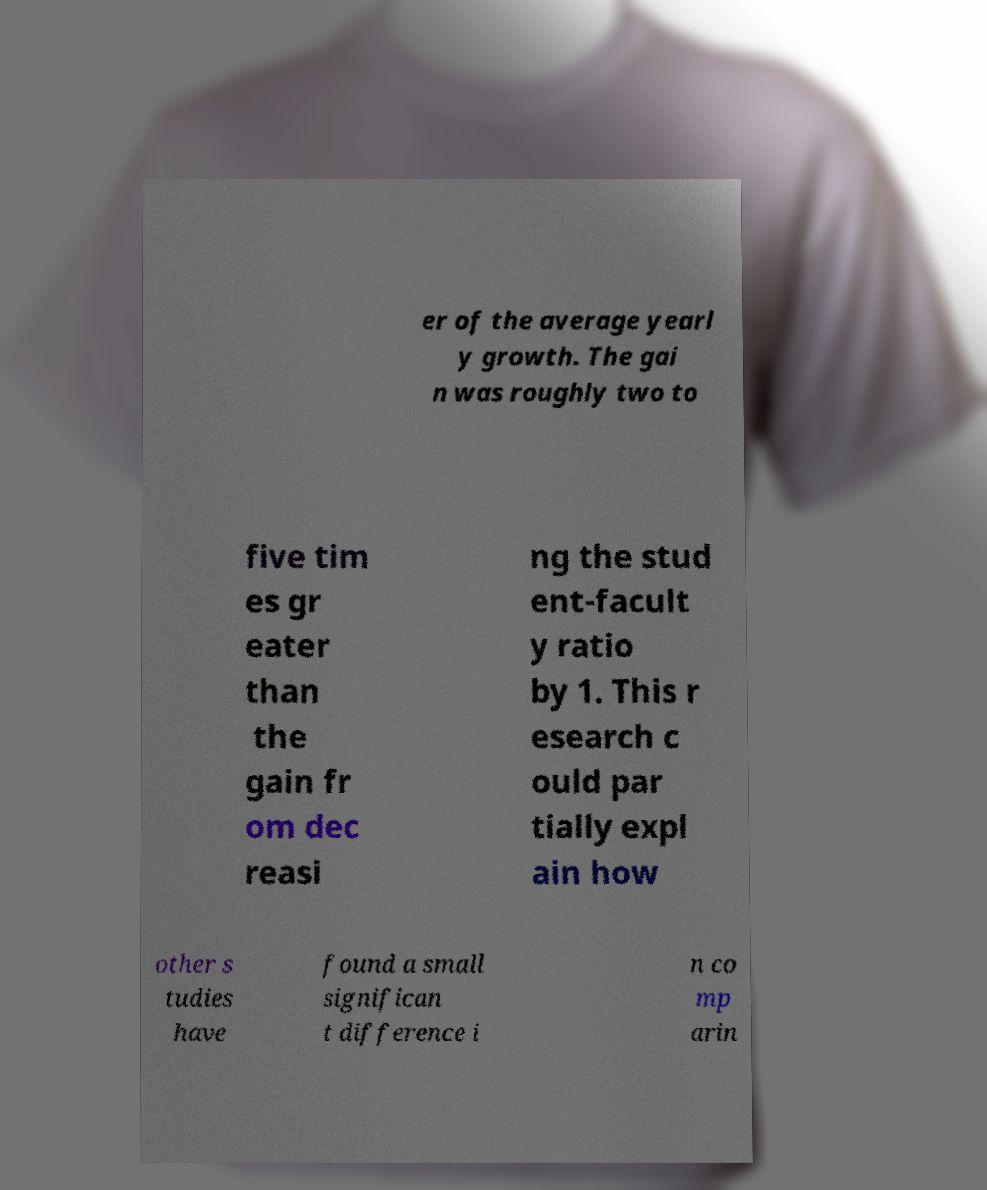Can you read and provide the text displayed in the image?This photo seems to have some interesting text. Can you extract and type it out for me? er of the average yearl y growth. The gai n was roughly two to five tim es gr eater than the gain fr om dec reasi ng the stud ent-facult y ratio by 1. This r esearch c ould par tially expl ain how other s tudies have found a small significan t difference i n co mp arin 